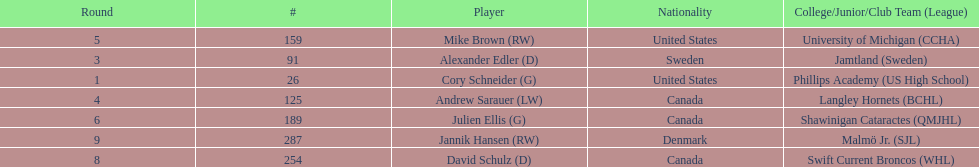What number of players have canada listed as their nationality? 3. 